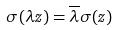Convert formula to latex. <formula><loc_0><loc_0><loc_500><loc_500>\sigma ( \lambda z ) = \overline { \lambda } \sigma ( z )</formula> 